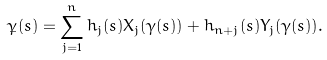Convert formula to latex. <formula><loc_0><loc_0><loc_500><loc_500>\dot { \gamma } ( s ) = \sum _ { j = 1 } ^ { n } h _ { j } ( s ) X _ { j } ( \gamma ( s ) ) + h _ { n + j } ( s ) Y _ { j } ( \gamma ( s ) ) .</formula> 